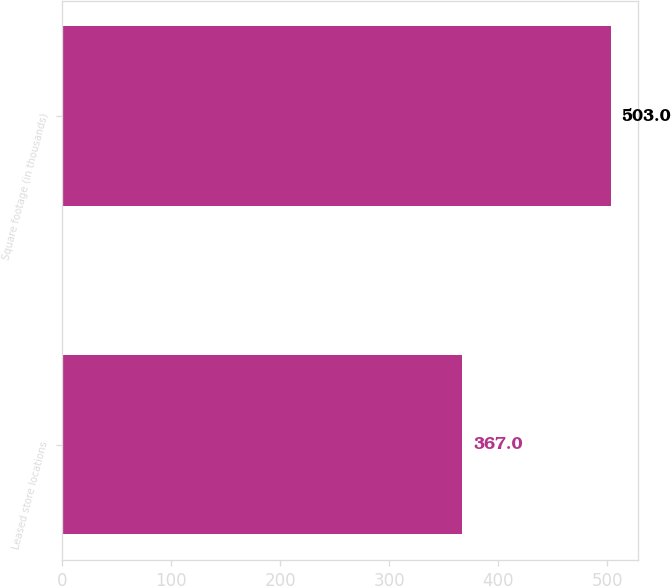Convert chart. <chart><loc_0><loc_0><loc_500><loc_500><bar_chart><fcel>Leased store locations<fcel>Square footage (in thousands)<nl><fcel>367<fcel>503<nl></chart> 